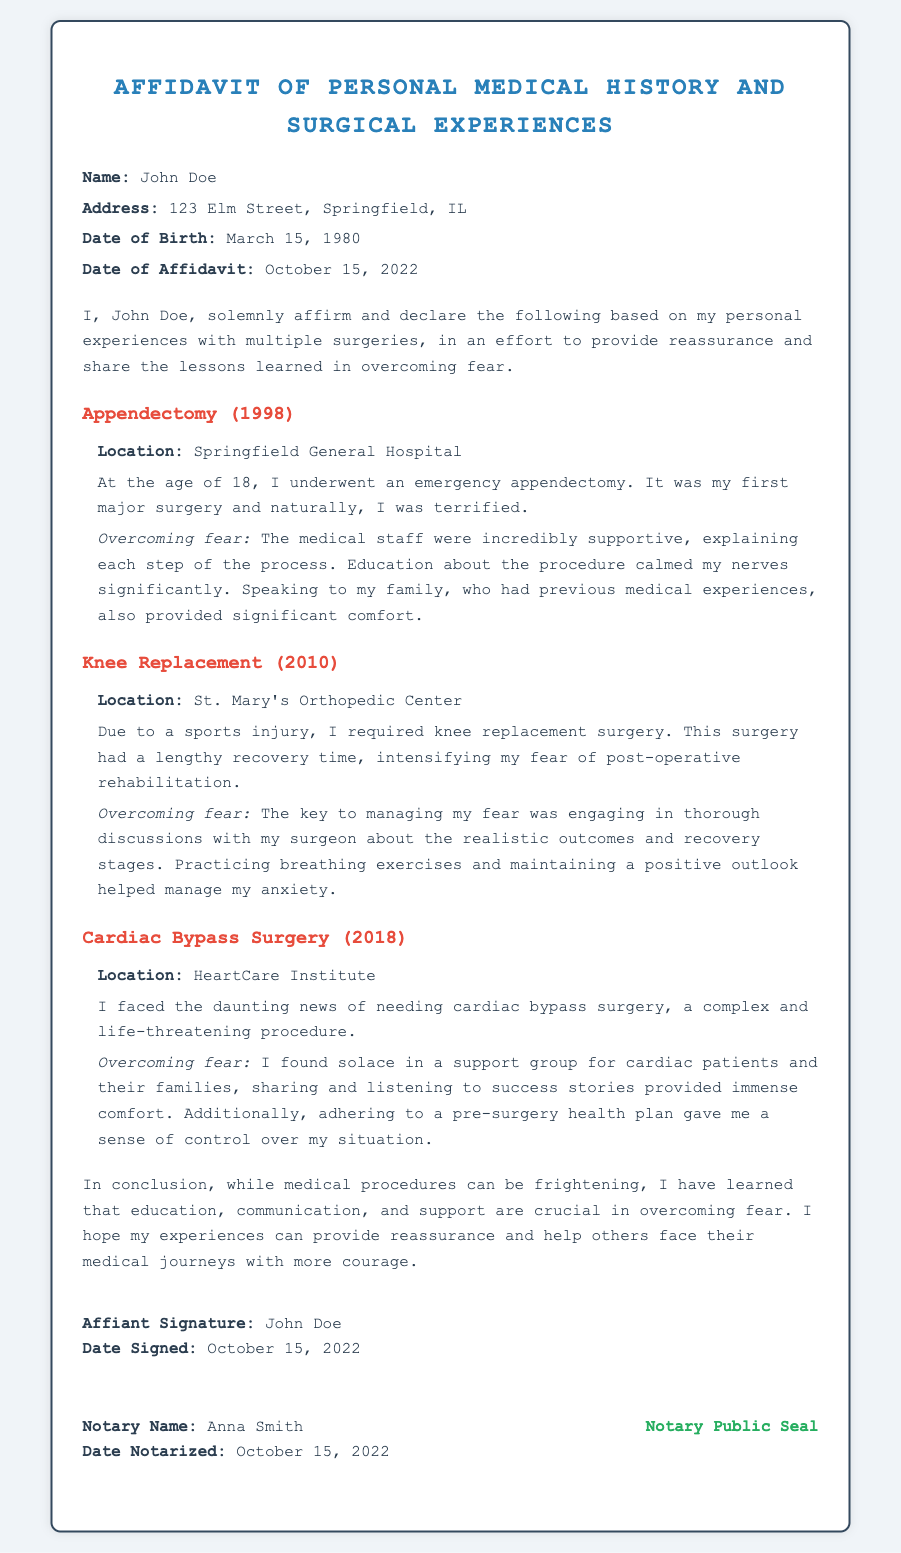What is the name of the affiant? The affiant’s name is stated in the document's header section.
Answer: John Doe What year did the appendectomy occur? The date of the appendectomy is given in the experience section, specifically mentioning "1998".
Answer: 1998 What was the location of the knee replacement surgery? The location of the knee replacement surgery is listed in the experience section.
Answer: St. Mary's Orthopedic Center What type of surgery did John Doe undergo in 2018? The type of surgery is mentioned in the experience section for the year 2018.
Answer: Cardiac Bypass Surgery What key strategy did John Doe use to manage his fear during his knee replacement surgery? This information is found in the experience section discussing overcoming fears related to his knee replacement.
Answer: Breathing exercises How many surgeries are mentioned in the affidavit? The count of surgeries can be found by reviewing the experiences shared in the document.
Answer: Three What is the date of the affidavit? The date of the affidavit is clearly mentioned in the document's header section.
Answer: October 15, 2022 What is the name of the notary public? The document states the notary's name in the notary section toward the end.
Answer: Anna Smith 